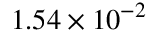<formula> <loc_0><loc_0><loc_500><loc_500>1 . 5 4 \times 1 0 ^ { - 2 }</formula> 